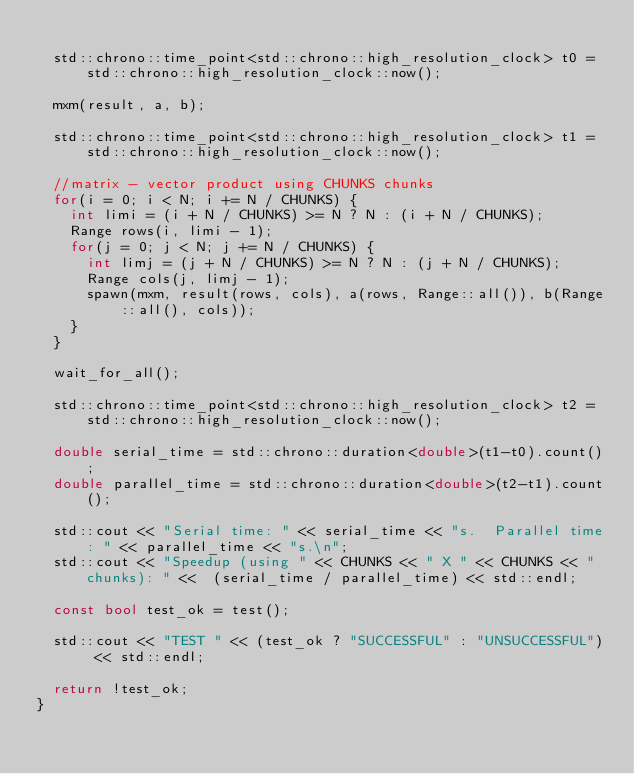Convert code to text. <code><loc_0><loc_0><loc_500><loc_500><_C++_>  
  std::chrono::time_point<std::chrono::high_resolution_clock> t0 = std::chrono::high_resolution_clock::now();
  
  mxm(result, a, b);
  
  std::chrono::time_point<std::chrono::high_resolution_clock> t1 = std::chrono::high_resolution_clock::now();
  
  //matrix - vector product using CHUNKS chunks
  for(i = 0; i < N; i += N / CHUNKS) {
    int limi = (i + N / CHUNKS) >= N ? N : (i + N / CHUNKS);
    Range rows(i, limi - 1);
    for(j = 0; j < N; j += N / CHUNKS) {
      int limj = (j + N / CHUNKS) >= N ? N : (j + N / CHUNKS);
      Range cols(j, limj - 1);
      spawn(mxm, result(rows, cols), a(rows, Range::all()), b(Range::all(), cols));
    }
  }
 
  wait_for_all();
  
  std::chrono::time_point<std::chrono::high_resolution_clock> t2 = std::chrono::high_resolution_clock::now();
  
  double serial_time = std::chrono::duration<double>(t1-t0).count();
  double parallel_time = std::chrono::duration<double>(t2-t1).count();
  
  std::cout << "Serial time: " << serial_time << "s.  Parallel time: " << parallel_time << "s.\n";
  std::cout << "Speedup (using " << CHUNKS << " X " << CHUNKS << " chunks): " <<  (serial_time / parallel_time) << std::endl;
  
  const bool test_ok = test();
  
  std::cout << "TEST " << (test_ok ? "SUCCESSFUL" : "UNSUCCESSFUL") << std::endl;
  
  return !test_ok;
}
</code> 